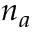Convert formula to latex. <formula><loc_0><loc_0><loc_500><loc_500>n _ { a }</formula> 